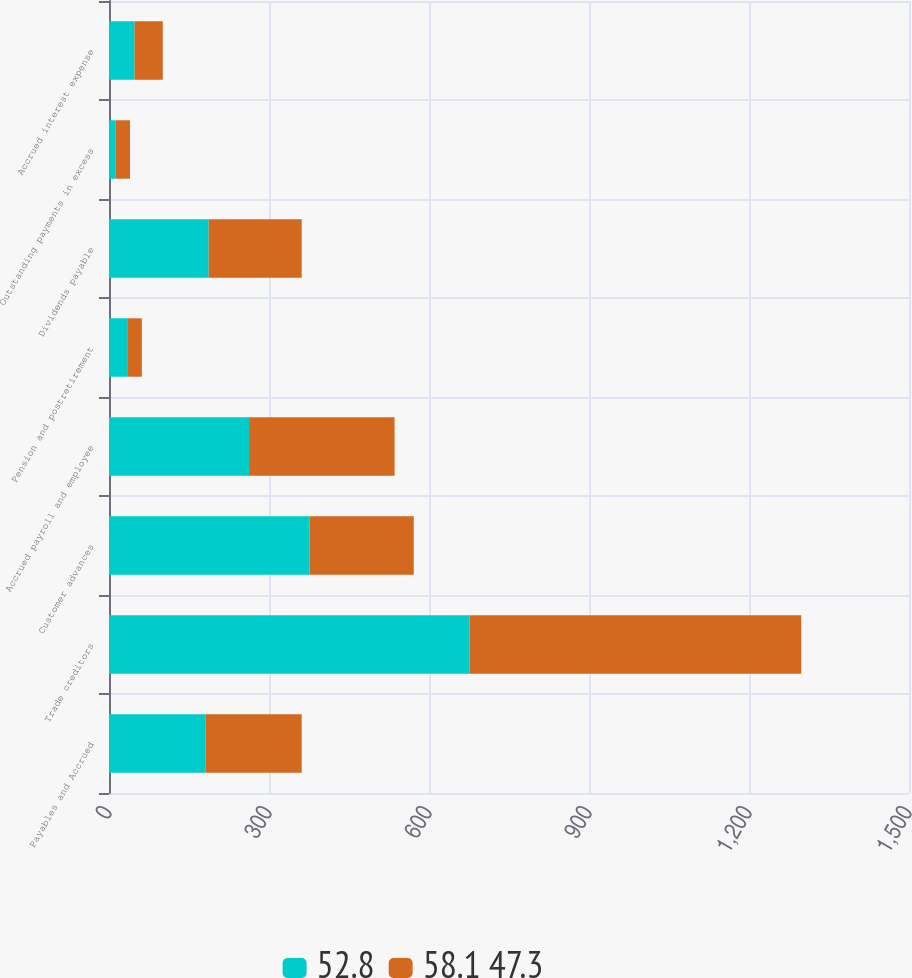Convert chart. <chart><loc_0><loc_0><loc_500><loc_500><stacked_bar_chart><ecel><fcel>Payables and Accrued<fcel>Trade creditors<fcel>Customer advances<fcel>Accrued payroll and employee<fcel>Pension and postretirement<fcel>Dividends payable<fcel>Outstanding payments in excess<fcel>Accrued interest expense<nl><fcel>52.8<fcel>180.65<fcel>676.1<fcel>376.1<fcel>262.6<fcel>35.5<fcel>186.9<fcel>11.9<fcel>47.9<nl><fcel>58.1 47.3<fcel>180.65<fcel>621.9<fcel>195.3<fcel>272.9<fcel>26.1<fcel>174.4<fcel>27.5<fcel>52.9<nl></chart> 